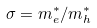Convert formula to latex. <formula><loc_0><loc_0><loc_500><loc_500>\sigma = m _ { e } ^ { * } / m _ { h } ^ { * }</formula> 